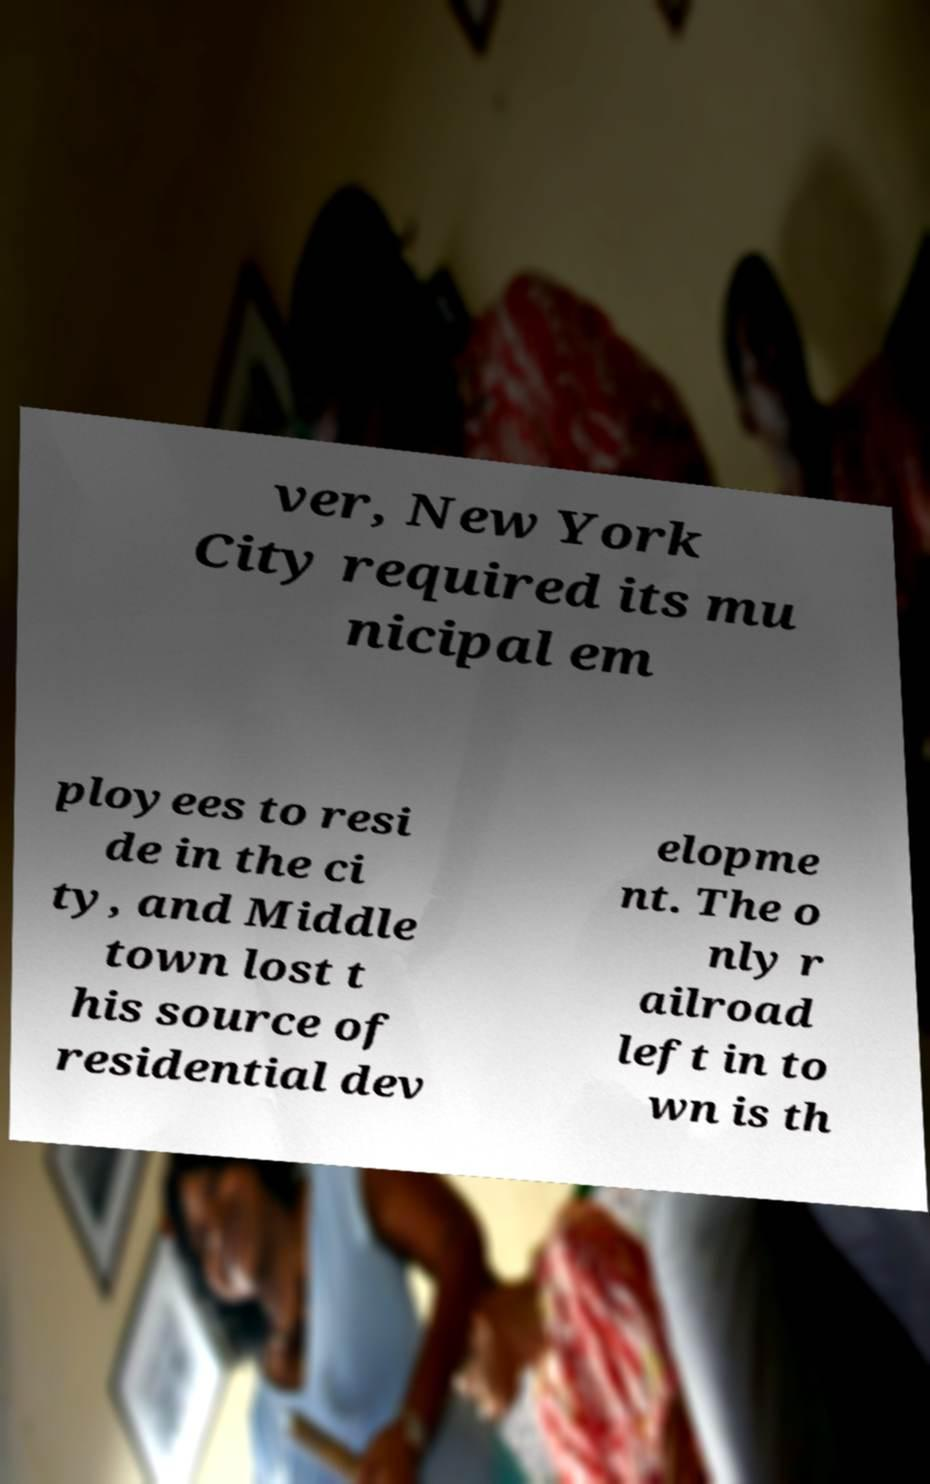Could you extract and type out the text from this image? ver, New York City required its mu nicipal em ployees to resi de in the ci ty, and Middle town lost t his source of residential dev elopme nt. The o nly r ailroad left in to wn is th 